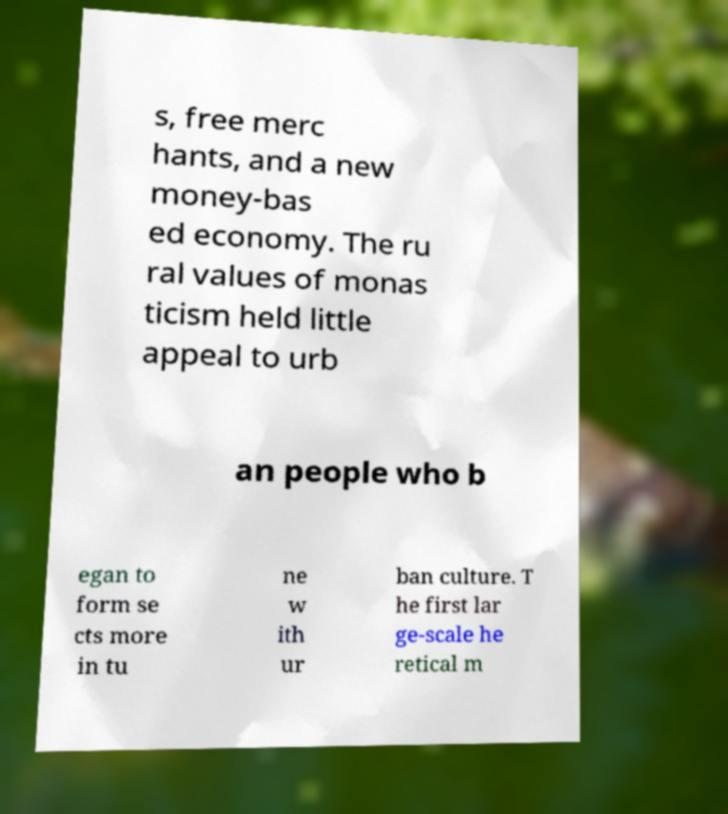Please read and relay the text visible in this image. What does it say? s, free merc hants, and a new money-bas ed economy. The ru ral values of monas ticism held little appeal to urb an people who b egan to form se cts more in tu ne w ith ur ban culture. T he first lar ge-scale he retical m 